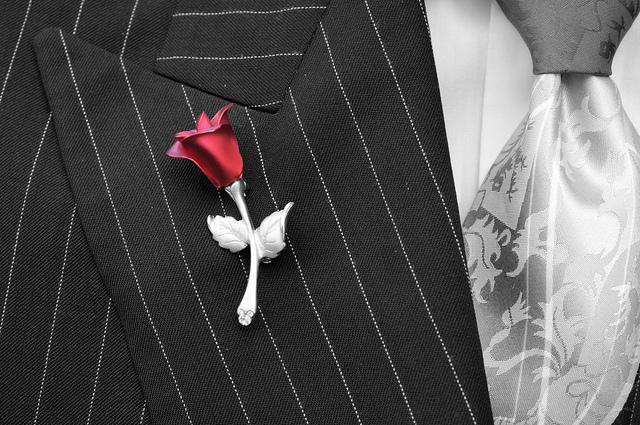How many train cars have yellow on them?
Give a very brief answer. 0. 